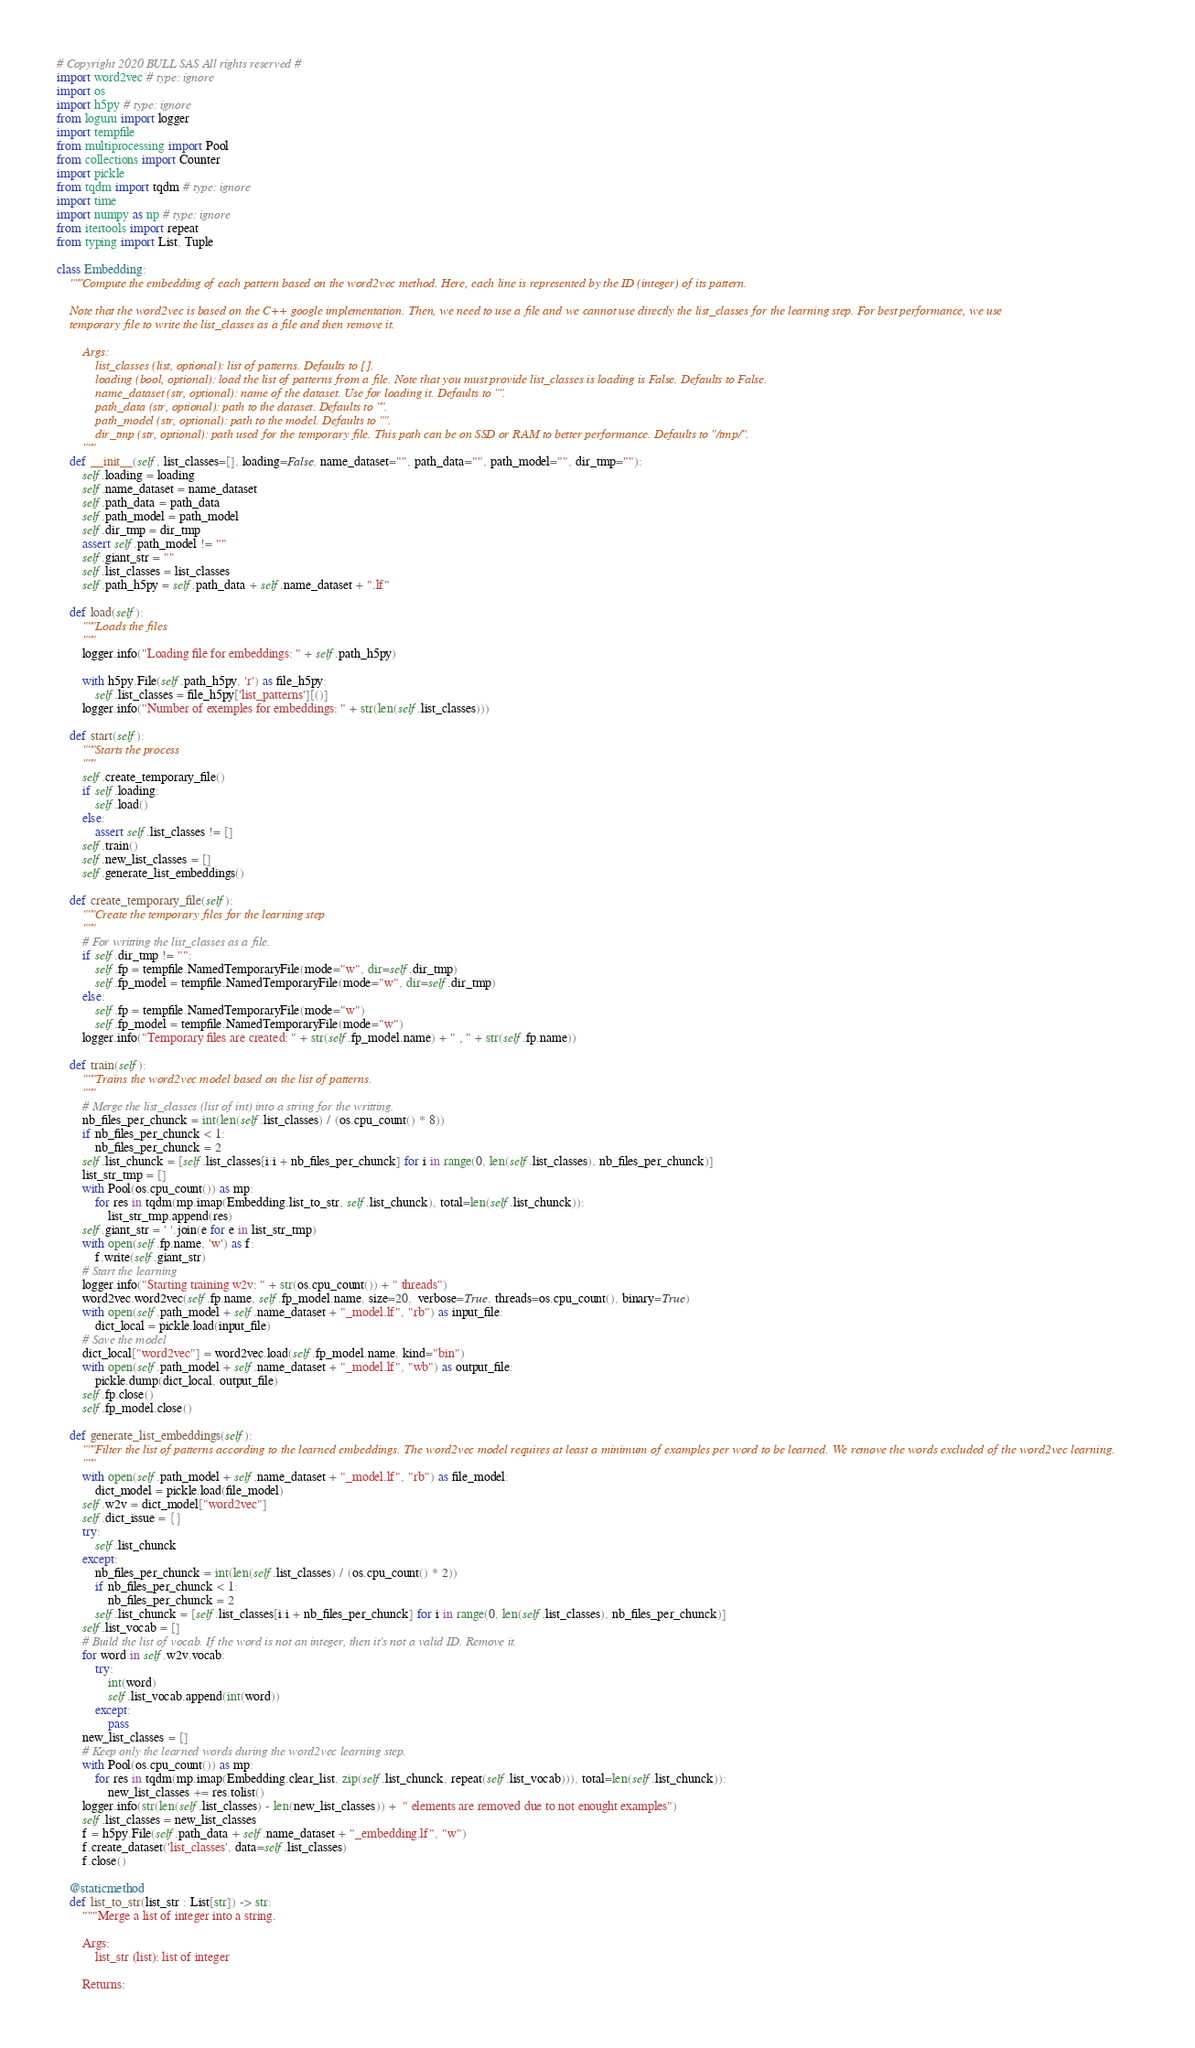Convert code to text. <code><loc_0><loc_0><loc_500><loc_500><_Python_># Copyright 2020 BULL SAS All rights reserved #
import word2vec # type: ignore
import os
import h5py # type: ignore
from loguru import logger
import tempfile
from multiprocessing import Pool
from collections import Counter
import pickle
from tqdm import tqdm # type: ignore
import time
import numpy as np # type: ignore
from itertools import repeat
from typing import List, Tuple

class Embedding:
    """Compute the embedding of each pattern based on the word2vec method. Here, each line is represented by the ID (integer) of its pattern.

    Note that the word2vec is based on the C++ google implementation. Then, we need to use a file and we cannot use directly the list_classes for the learning step. For best performance, we use
    temporary file to write the list_classes as a file and then remove it.

        Args:
            list_classes (list, optional): list of patterns. Defaults to [].
            loading (bool, optional): load the list of patterns from a file. Note that you must provide list_classes is loading is False. Defaults to False.
            name_dataset (str, optional): name of the dataset. Use for loading it. Defaults to "".
            path_data (str, optional): path to the dataset. Defaults to "".
            path_model (str, optional): path to the model. Defaults to "".
            dir_tmp (str, optional): path used for the temporary file. This path can be on SSD or RAM to better performance. Defaults to "/tmp/".
        """
    def __init__(self, list_classes=[], loading=False, name_dataset="", path_data="", path_model="", dir_tmp=""):
        self.loading = loading
        self.name_dataset = name_dataset
        self.path_data = path_data
        self.path_model = path_model
        self.dir_tmp = dir_tmp
        assert self.path_model != ""
        self.giant_str = ""
        self.list_classes = list_classes
        self.path_h5py = self.path_data + self.name_dataset + ".lf"

    def load(self):
        """Loads the files
        """
        logger.info("Loading file for embeddings: " + self.path_h5py)

        with h5py.File(self.path_h5py, 'r') as file_h5py:
            self.list_classes = file_h5py['list_patterns'][()]
        logger.info("Number of exemples for embeddings: " + str(len(self.list_classes)))

    def start(self):
        """Starts the process
        """
        self.create_temporary_file()
        if self.loading:
            self.load()
        else:
            assert self.list_classes != []
        self.train()
        self.new_list_classes = []
        self.generate_list_embeddings()

    def create_temporary_file(self):
        """Create the temporary files for the learning step
        """
        # For writting the list_classes as a file.
        if self.dir_tmp != "":
            self.fp = tempfile.NamedTemporaryFile(mode="w", dir=self.dir_tmp)
            self.fp_model = tempfile.NamedTemporaryFile(mode="w", dir=self.dir_tmp)
        else:
            self.fp = tempfile.NamedTemporaryFile(mode="w")
            self.fp_model = tempfile.NamedTemporaryFile(mode="w")
        logger.info("Temporary files are created: " + str(self.fp_model.name) + " , " + str(self.fp.name))

    def train(self):
        """Trains the word2vec model based on the list of patterns.
        """
        # Merge the list_classes (list of int) into a string for the writting.
        nb_files_per_chunck = int(len(self.list_classes) / (os.cpu_count() * 8))
        if nb_files_per_chunck < 1:
            nb_files_per_chunck = 2
        self.list_chunck = [self.list_classes[i:i + nb_files_per_chunck] for i in range(0, len(self.list_classes), nb_files_per_chunck)]
        list_str_tmp = []
        with Pool(os.cpu_count()) as mp:
            for res in tqdm(mp.imap(Embedding.list_to_str, self.list_chunck), total=len(self.list_chunck)):
                list_str_tmp.append(res)
        self.giant_str = ' '.join(e for e in list_str_tmp)
        with open(self.fp.name, 'w') as f:
            f.write(self.giant_str)
        # Start the learning
        logger.info("Starting training w2v: " + str(os.cpu_count()) + " threads")
        word2vec.word2vec(self.fp.name, self.fp_model.name, size=20,  verbose=True, threads=os.cpu_count(), binary=True)
        with open(self.path_model + self.name_dataset + "_model.lf", "rb") as input_file:
            dict_local = pickle.load(input_file)
        # Save the model
        dict_local["word2vec"] = word2vec.load(self.fp_model.name, kind="bin")
        with open(self.path_model + self.name_dataset + "_model.lf", "wb") as output_file:
            pickle.dump(dict_local, output_file)
        self.fp.close()
        self.fp_model.close()

    def generate_list_embeddings(self):
        """Filter the list of patterns according to the learned embeddings. The word2vec model requires at least a minimum of examples per word to be learned. We remove the words excluded of the word2vec learning.
        """
        with open(self.path_model + self.name_dataset + "_model.lf", "rb") as file_model:
            dict_model = pickle.load(file_model)
        self.w2v = dict_model["word2vec"]
        self.dict_issue = {}
        try:
            self.list_chunck
        except:
            nb_files_per_chunck = int(len(self.list_classes) / (os.cpu_count() * 2))
            if nb_files_per_chunck < 1:
                nb_files_per_chunck = 2
            self.list_chunck = [self.list_classes[i:i + nb_files_per_chunck] for i in range(0, len(self.list_classes), nb_files_per_chunck)]
        self.list_vocab = []
        # Build the list of vocab. If the word is not an integer, then it's not a valid ID. Remove it.
        for word in self.w2v.vocab:
            try:
                int(word)
                self.list_vocab.append(int(word))
            except:
                pass
        new_list_classes = []
        # Keep only the learned words during the word2vec learning step.
        with Pool(os.cpu_count()) as mp:
            for res in tqdm(mp.imap(Embedding.clear_list, zip(self.list_chunck, repeat(self.list_vocab))), total=len(self.list_chunck)):
                new_list_classes += res.tolist()
        logger.info(str(len(self.list_classes) - len(new_list_classes)) +  " elements are removed due to not enought examples")
        self.list_classes = new_list_classes
        f = h5py.File(self.path_data + self.name_dataset + "_embedding.lf", "w")
        f.create_dataset('list_classes', data=self.list_classes)
        f.close()

    @staticmethod
    def list_to_str(list_str : List[str]) -> str:
        """Merge a list of integer into a string.

        Args:
            list_str (list): list of integer

        Returns:</code> 